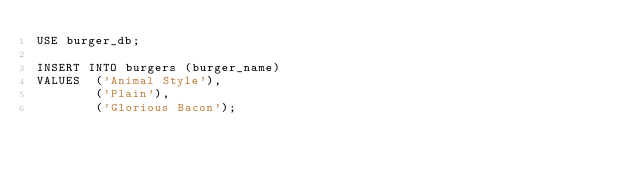Convert code to text. <code><loc_0><loc_0><loc_500><loc_500><_SQL_>USE burger_db;

INSERT INTO burgers (burger_name)
VALUES 	('Animal Style'),
        ('Plain'),
        ('Glorious Bacon');</code> 